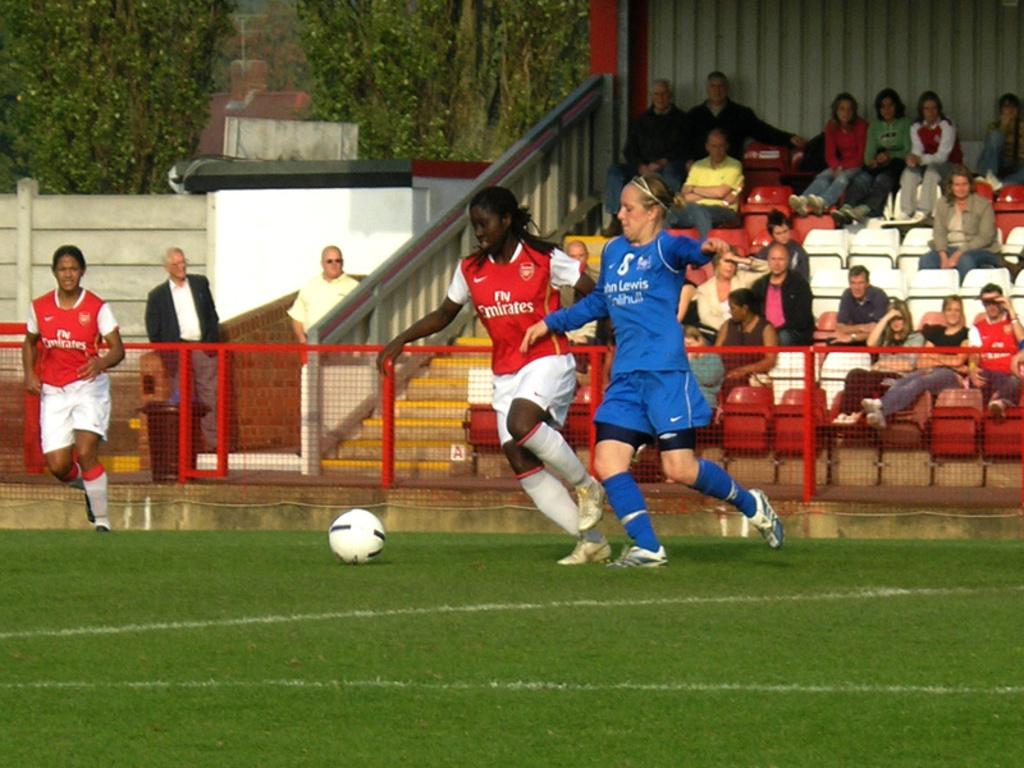<image>
Write a terse but informative summary of the picture. Women are playing soccer and the woman in red's jersey says "Fly Emirates." 